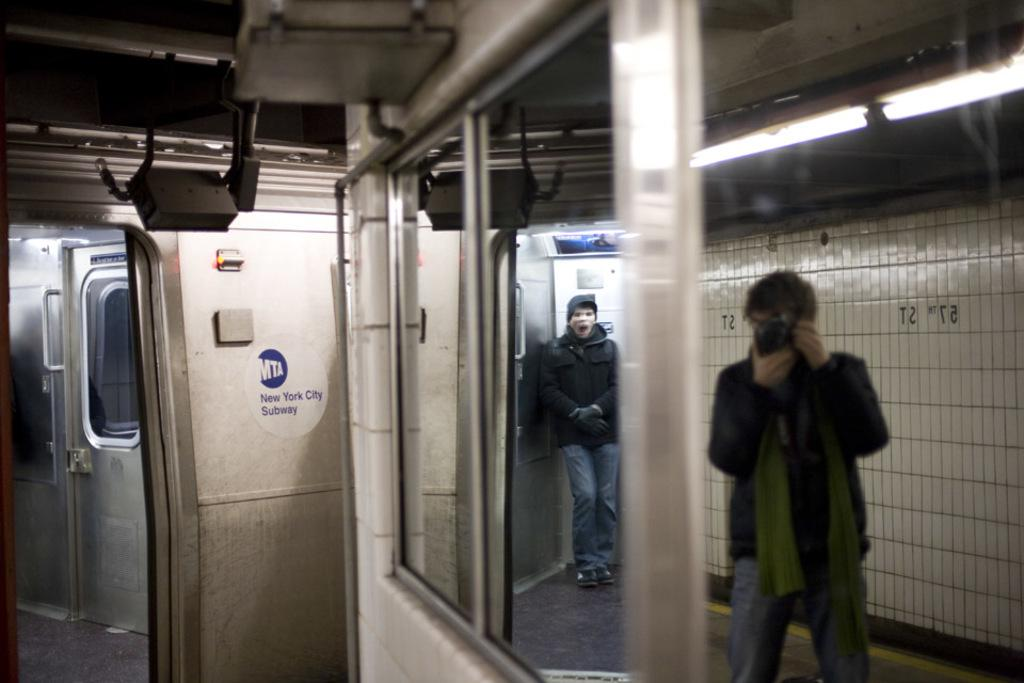Provide a one-sentence caption for the provided image. A view of the MTA New York Subway with someone taking a picture. 